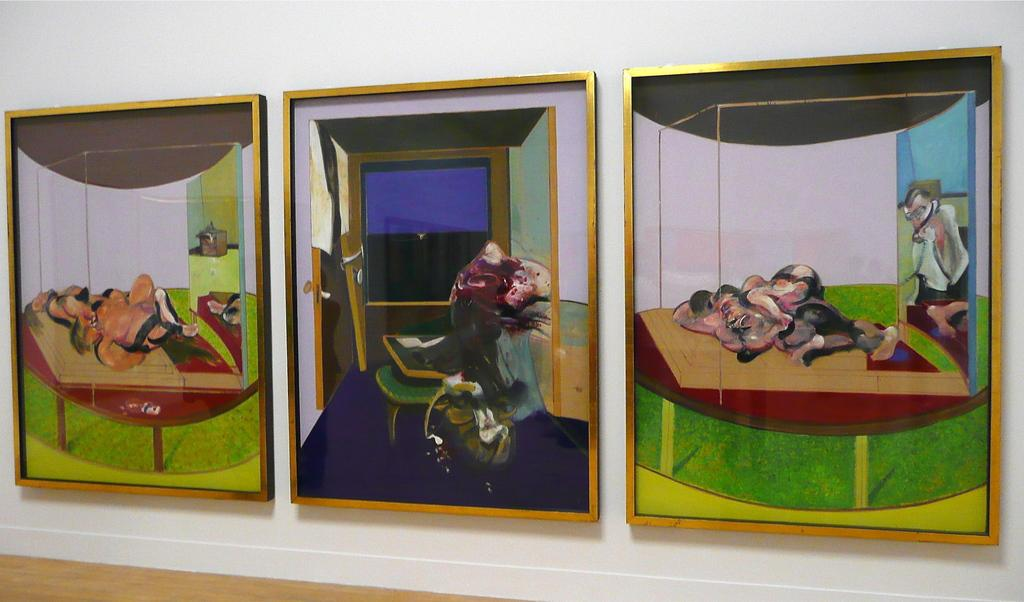What is the primary color of the wall in the image? The wall in the image is white. How many photo frames are on the wall? There are three photo frames on the wall. Can you describe the setting of the image? The image was likely taken inside a room, as there is a wall with photo frames. What type of lettuce is growing on the wall in the image? There is no lettuce present in the image; it features a white wall with photo frames. 